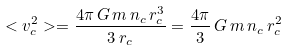<formula> <loc_0><loc_0><loc_500><loc_500>< v _ { c } ^ { 2 } > = \frac { 4 \pi \, G \, m \, n _ { c } \, r _ { c } ^ { 3 } } { 3 \, r _ { c } } = \frac { 4 \pi } { 3 } \, G \, m \, n _ { c } \, r _ { c } ^ { 2 }</formula> 